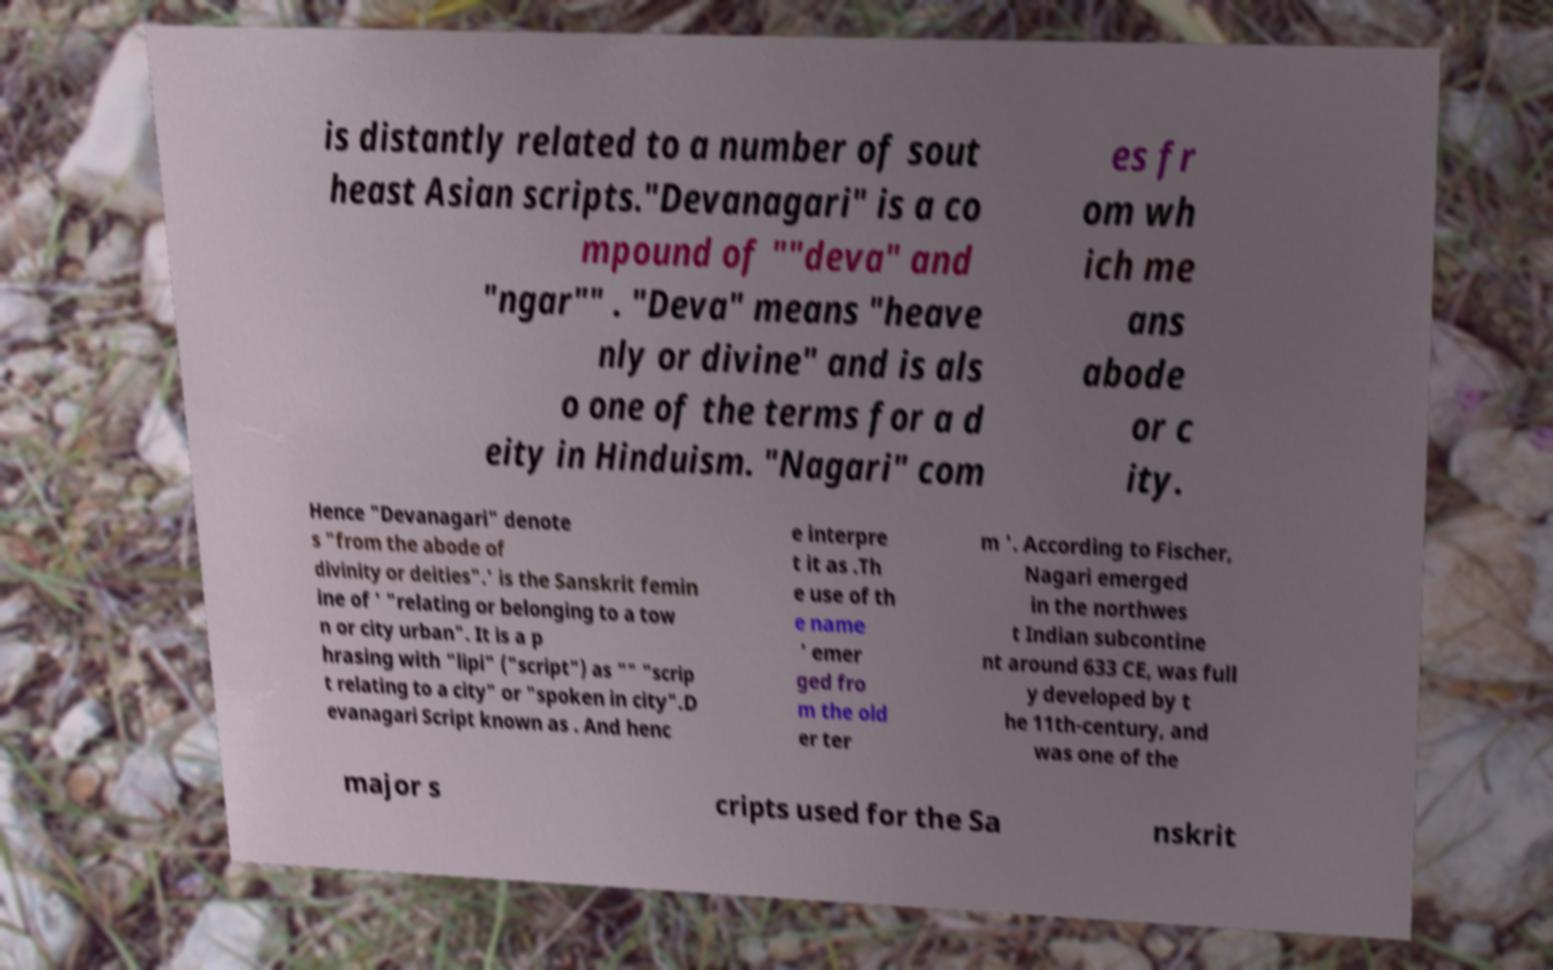Could you assist in decoding the text presented in this image and type it out clearly? is distantly related to a number of sout heast Asian scripts."Devanagari" is a co mpound of ""deva" and "ngar"" . "Deva" means "heave nly or divine" and is als o one of the terms for a d eity in Hinduism. "Nagari" com es fr om wh ich me ans abode or c ity. Hence "Devanagari" denote s "from the abode of divinity or deities".' is the Sanskrit femin ine of ' "relating or belonging to a tow n or city urban". It is a p hrasing with "lipi" ("script") as "" "scrip t relating to a city" or "spoken in city".D evanagari Script known as . And henc e interpre t it as .Th e use of th e name ' emer ged fro m the old er ter m '. According to Fischer, Nagari emerged in the northwes t Indian subcontine nt around 633 CE, was full y developed by t he 11th-century, and was one of the major s cripts used for the Sa nskrit 